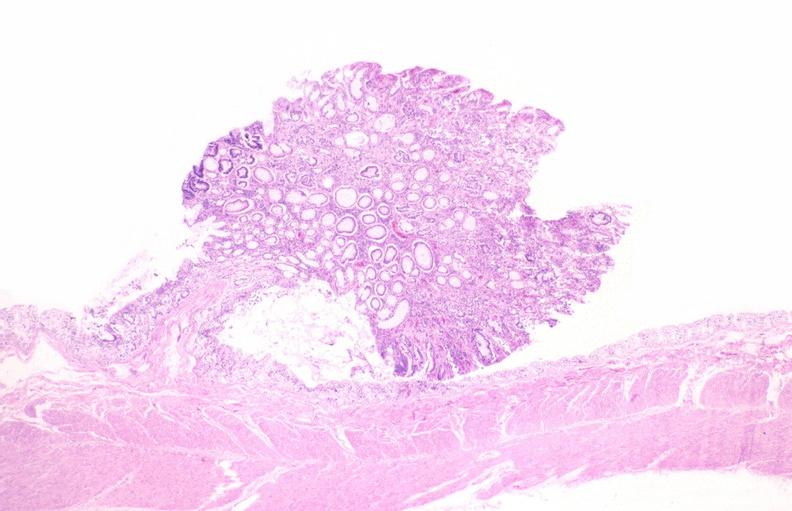where is this from?
Answer the question using a single word or phrase. Gastrointestinal system 